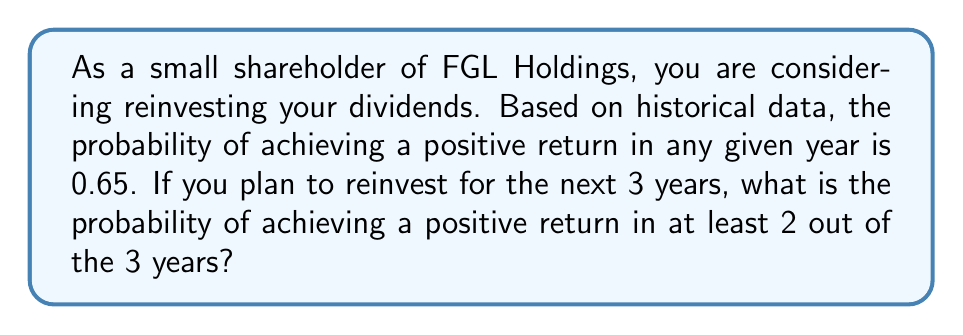Show me your answer to this math problem. To solve this problem, we can use the binomial probability distribution. Let's break it down step by step:

1) We are looking for the probability of achieving a positive return in at least 2 out of 3 years. This can happen in two ways:
   a) Positive return in exactly 2 years
   b) Positive return in all 3 years

2) Let's define our variables:
   $n = 3$ (number of years)
   $p = 0.65$ (probability of positive return in any given year)
   $q = 1 - p = 0.35$ (probability of not achieving a positive return)

3) The probability of exactly $k$ successes in $n$ trials is given by the binomial probability formula:

   $P(X = k) = \binom{n}{k} p^k q^{n-k}$

4) For exactly 2 successes in 3 years:
   $P(X = 2) = \binom{3}{2} (0.65)^2 (0.35)^1$
   
   $= 3 \cdot 0.65^2 \cdot 0.35$
   $= 3 \cdot 0.4225 \cdot 0.35$
   $= 0.44363$

5) For 3 successes in 3 years:
   $P(X = 3) = \binom{3}{3} (0.65)^3 (0.35)^0$
   
   $= 1 \cdot 0.65^3$
   $= 0.274625$

6) The probability of at least 2 successes is the sum of these probabilities:

   $P(X \geq 2) = P(X = 2) + P(X = 3)$
   $= 0.44363 + 0.274625$
   $= 0.718255$

Therefore, the probability of achieving a positive return in at least 2 out of the 3 years is approximately 0.718255 or 71.83%.
Answer: The probability of achieving a positive return in at least 2 out of 3 years is approximately 0.718255 or 71.83%. 